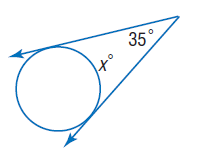Question: Find x. Assume that segments that appear to be tangent are tangent.
Choices:
A. 35
B. 70
C. 145
D. 155
Answer with the letter. Answer: C 